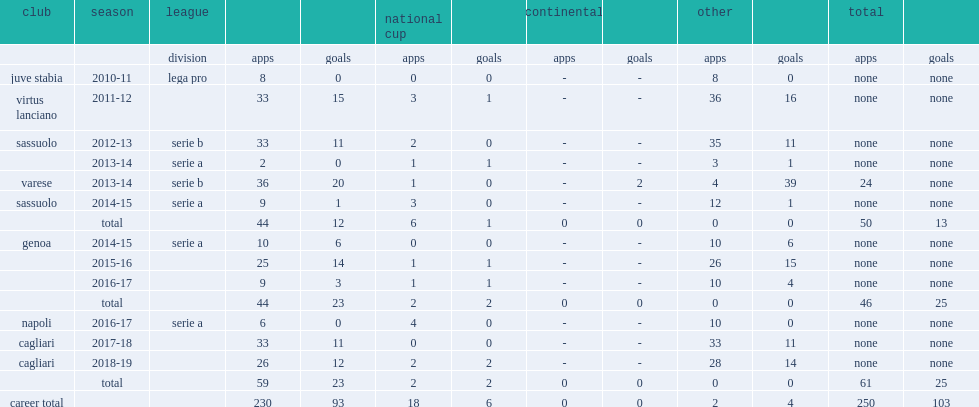Which club did leonardo pavoletti play for in 2011-12? Virtus lanciano. 